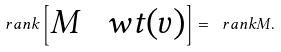Convert formula to latex. <formula><loc_0><loc_0><loc_500><loc_500>\ r a n k \begin{bmatrix} M & \ w t ( v ) \end{bmatrix} = \ r a n k M .</formula> 